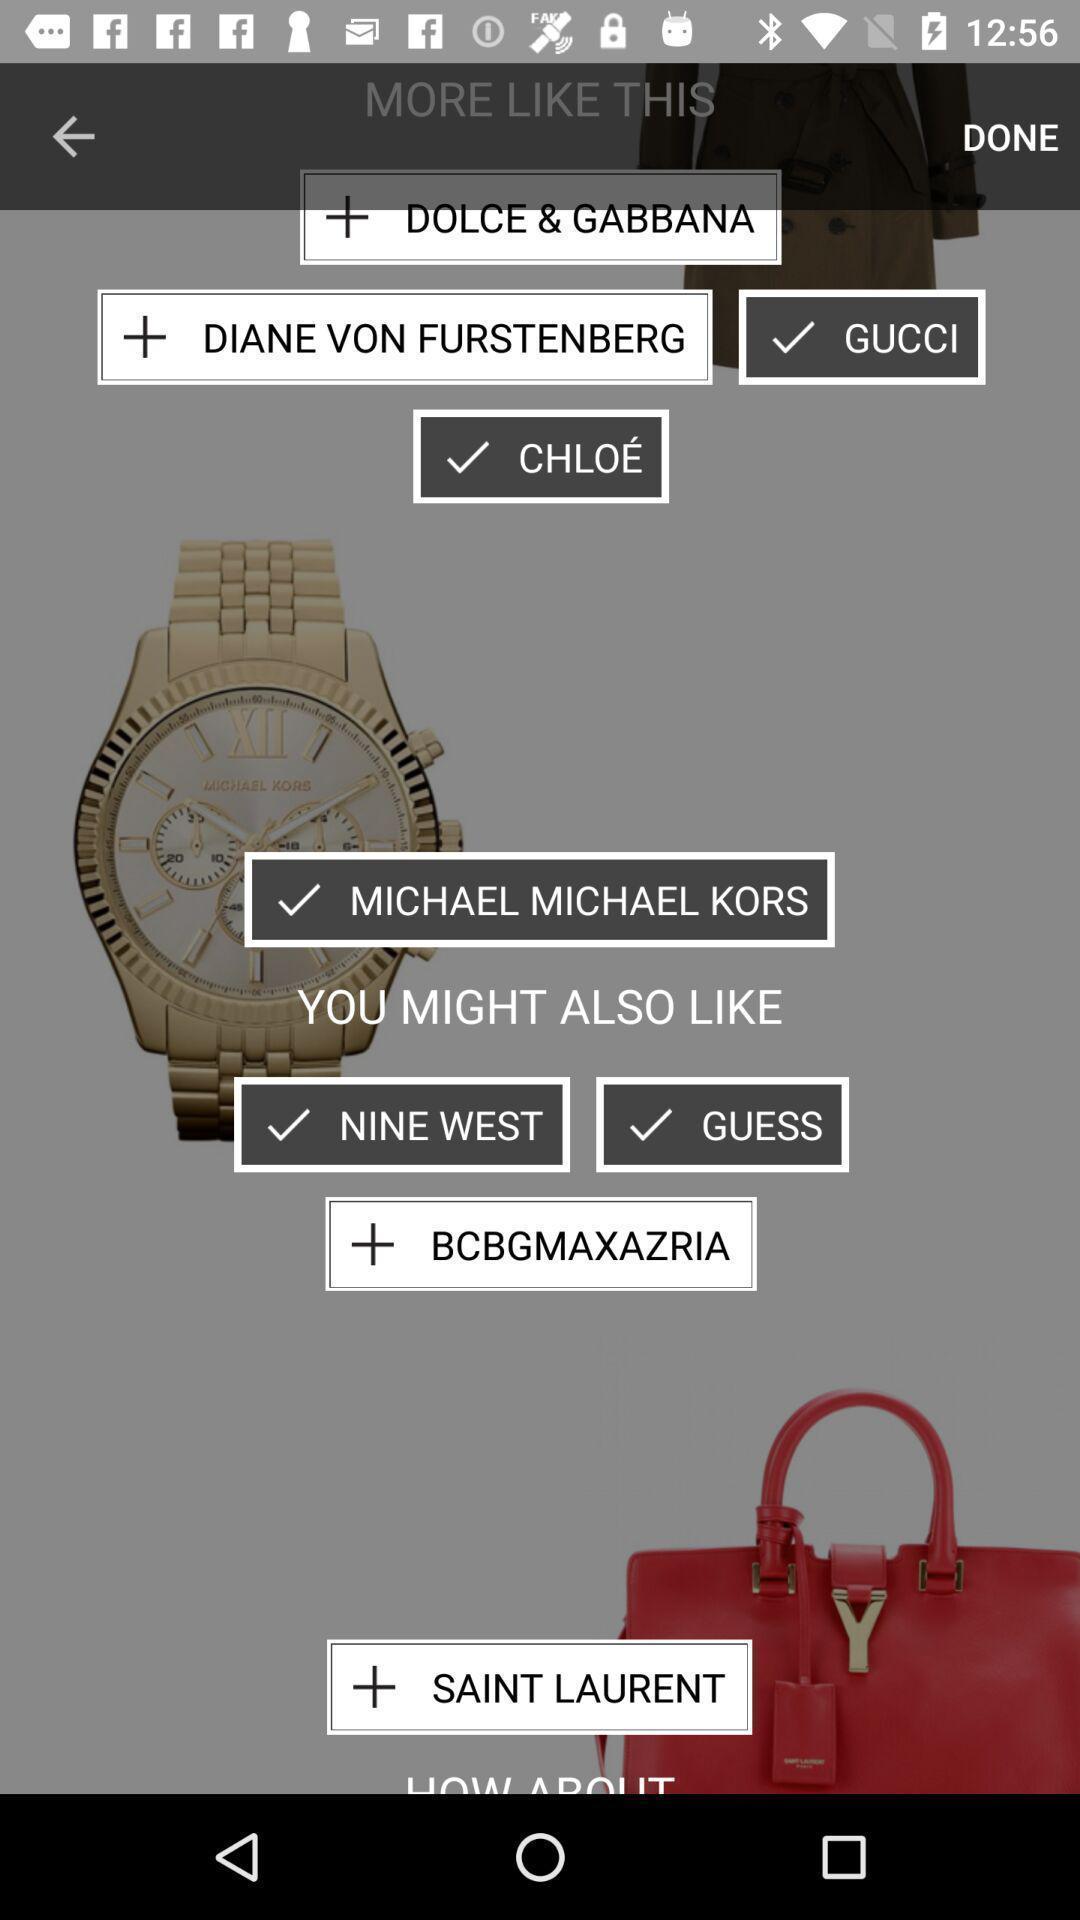Explain what's happening in this screen capture. Screen shows different options in a shopping app. 